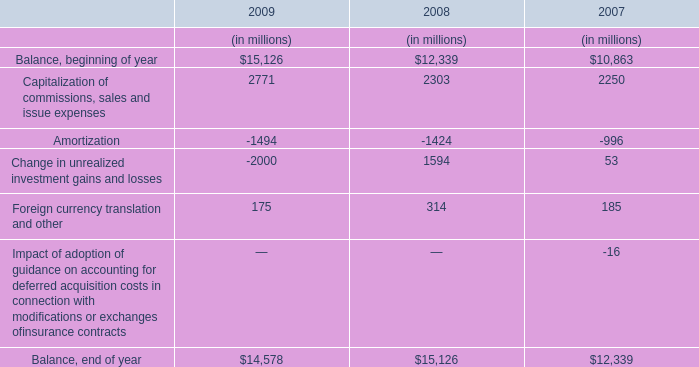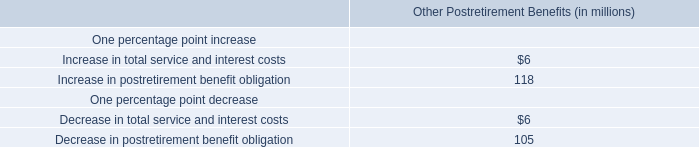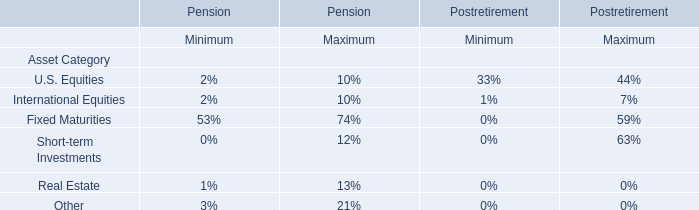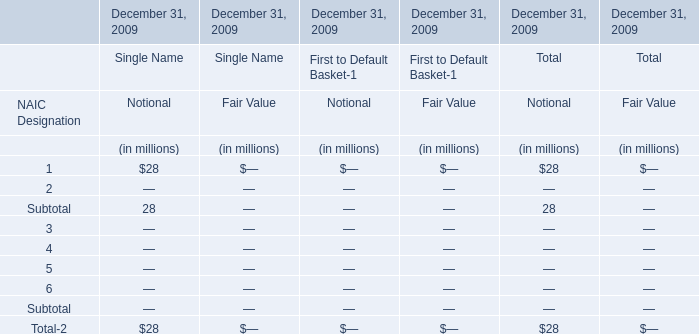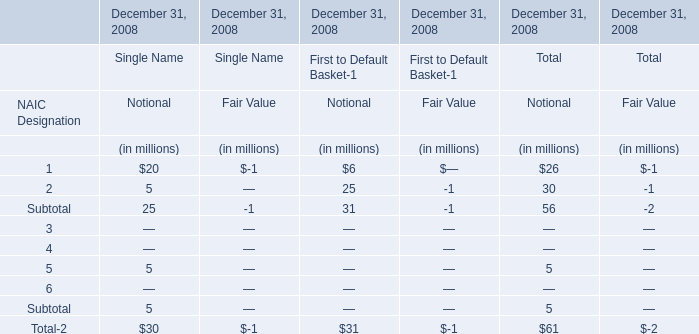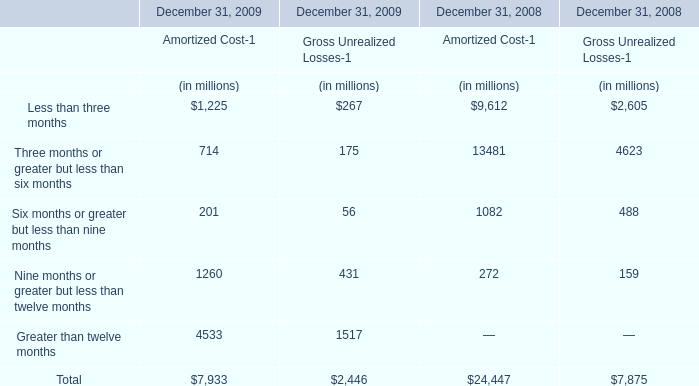How many Amortized Cost-1exceed the average of Amortized Cost-1 in 2009? 
Answer: 1. 